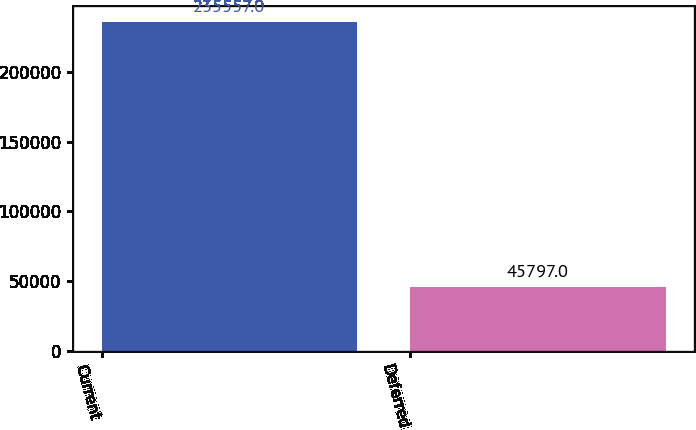Convert chart to OTSL. <chart><loc_0><loc_0><loc_500><loc_500><bar_chart><fcel>Current<fcel>Deferred<nl><fcel>235557<fcel>45797<nl></chart> 